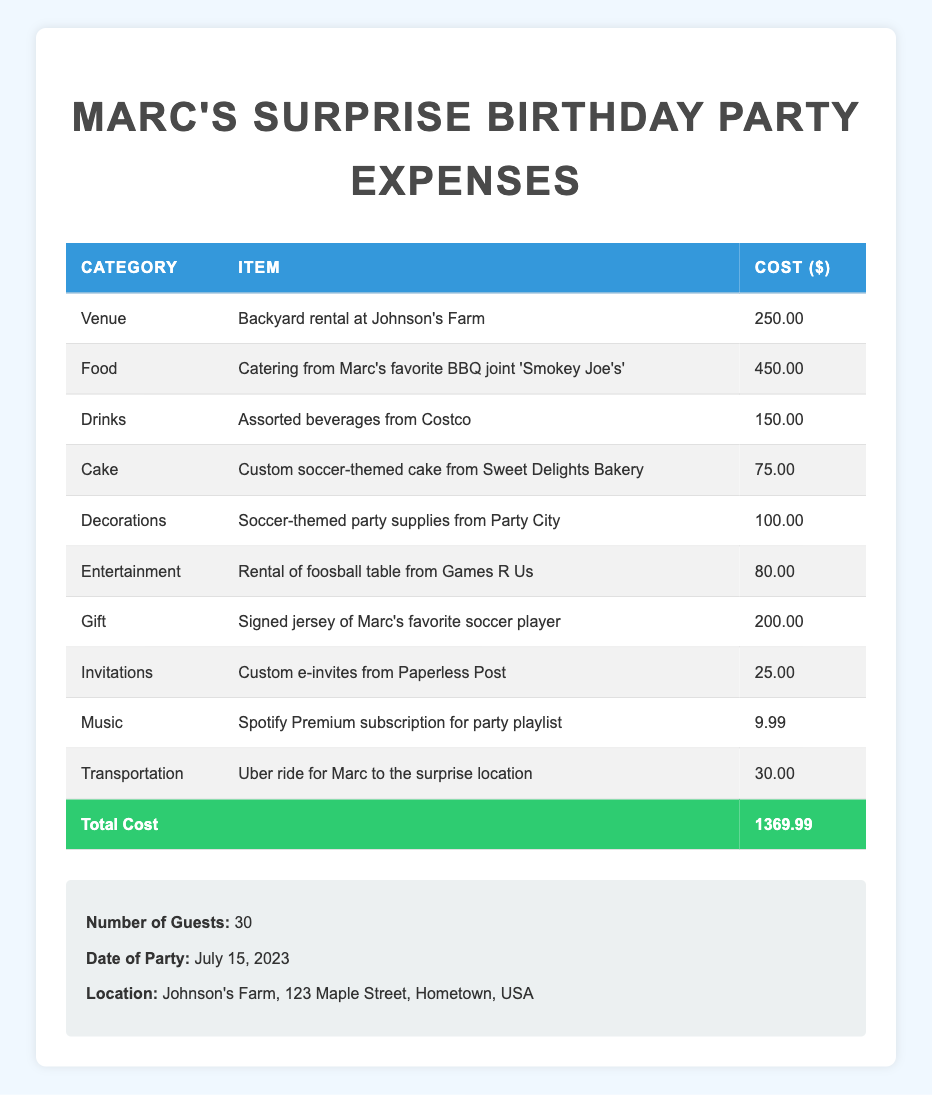What is the total cost of the party? The total cost is displayed in the last row of the table, which states "Total Cost" and its corresponding value. The total cost is 1369.99.
Answer: 1369.99 How much was spent on food? In the table, under the "Food" category, there is a specific item listed with its cost. The catering expense from "Smokey Joe's" is given as 450.00.
Answer: 450.00 Is the cake cost greater than the transportation cost? We look at the "Cake" and "Transportation" sections of the table. The cake costs 75.00 and the transportation costs 30.00. Since 75.00 is greater than 30.00, the statement is true.
Answer: Yes What is the combined cost of drinks and decorations? First, we find the cost of drinks, which is 150.00, and the cost of decorations, which is 100.00. We then add these two amounts together: 150.00 + 100.00 = 250.00.
Answer: 250.00 Which category had the highest expense? We check each category's total costs. The food category has the largest single item at 450.00, while others such as the gift category has 200.00 and the venue has 250.00. Since 450.00 is greater than any other expense, the highest expense is in the food category.
Answer: Food What was the cost of the invitations? In the table under the "Invitations" category, the cost of custom e-invites is specified as 25.00.
Answer: 25.00 How much more did the food cost than the cake? From the table, the food cost is 450.00 and the cake cost is 75.00. We subtract the cake cost from the food cost: 450.00 - 75.00 = 375.00.
Answer: 375.00 Does the total cost exceed 1300? We refer to the total cost of the party, which is 1369.99. Since this is indeed greater than 1300, the statement is true.
Answer: Yes What percentage of the total cost was spent on the gift? The gift costs 200.00. To find the percentage, we calculate 200.00 divided by the total cost (1369.99), then multiply by 100: (200.00 / 1369.99) * 100 ≈ 14.6.
Answer: Approximately 14.6% 